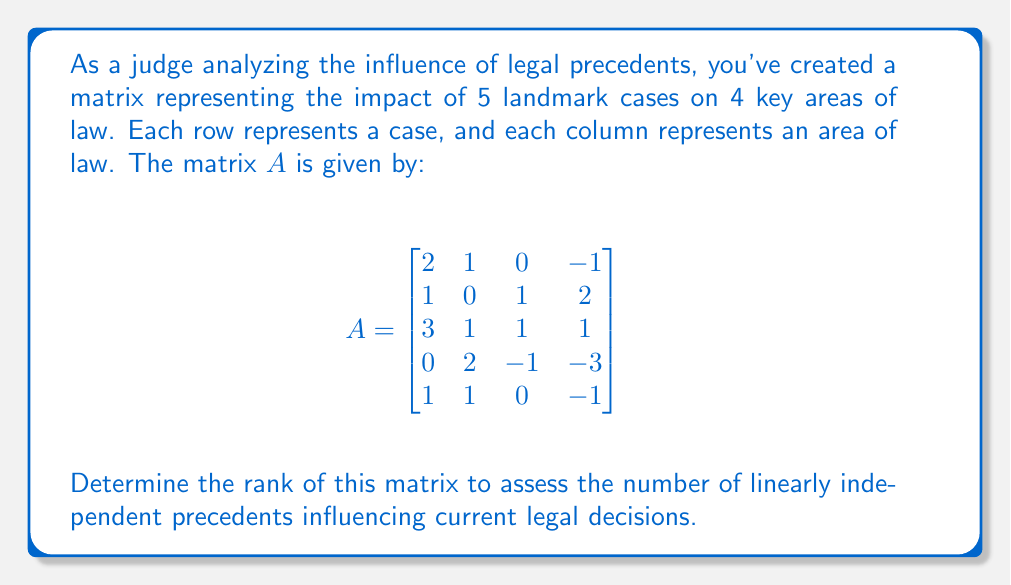Can you answer this question? To determine the rank of matrix $A$, we need to find the number of linearly independent rows or columns. We'll use the row echelon form method:

1) First, let's apply Gaussian elimination to get the matrix in row echelon form:

$$\begin{bmatrix}
2 & 1 & 0 & -1 \\
1 & 0 & 1 & 2 \\
3 & 1 & 1 & 1 \\
0 & 2 & -1 & -3 \\
1 & 1 & 0 & -1
\end{bmatrix} \sim
\begin{bmatrix}
2 & 1 & 0 & -1 \\
0 & -\frac{1}{2} & 1 & \frac{5}{2} \\
0 & -\frac{1}{2} & 1 & \frac{5}{2} \\
0 & 2 & -1 & -3 \\
0 & \frac{1}{2} & 0 & -\frac{1}{2}
\end{bmatrix}$$

2) Continue eliminating:

$$\sim \begin{bmatrix}
2 & 1 & 0 & -1 \\
0 & -\frac{1}{2} & 1 & \frac{5}{2} \\
0 & 0 & 0 & 0 \\
0 & 0 & -3 & -8 \\
0 & 0 & -\frac{1}{2} & -\frac{5}{4}
\end{bmatrix}$$

3) The resulting matrix is in row echelon form. The rank of the matrix is equal to the number of non-zero rows in this form.

4) We can see that there are 4 non-zero rows in the final row echelon form.

Therefore, the rank of matrix $A$ is 4.

This means that out of the 5 landmark cases, 4 provide linearly independent influences on the key areas of law, indicating a high degree of diversity in the legal precedents' impacts.
Answer: 4 